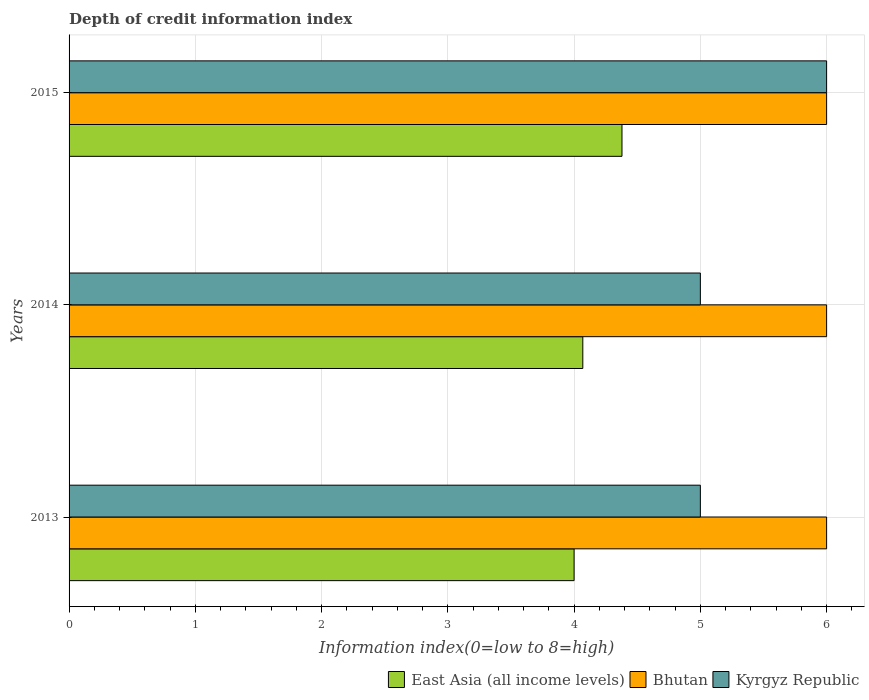How many groups of bars are there?
Provide a succinct answer. 3. Are the number of bars on each tick of the Y-axis equal?
Your answer should be compact. Yes. How many bars are there on the 1st tick from the bottom?
Ensure brevity in your answer.  3. Across all years, what is the maximum information index in East Asia (all income levels)?
Make the answer very short. 4.38. In which year was the information index in East Asia (all income levels) maximum?
Offer a very short reply. 2015. What is the total information index in Bhutan in the graph?
Your answer should be very brief. 18. What is the difference between the information index in Kyrgyz Republic in 2013 and the information index in Bhutan in 2015?
Your answer should be very brief. -1. What is the average information index in Bhutan per year?
Provide a short and direct response. 6. In the year 2013, what is the difference between the information index in Kyrgyz Republic and information index in East Asia (all income levels)?
Offer a terse response. 1. In how many years, is the information index in East Asia (all income levels) greater than 3.4 ?
Offer a terse response. 3. What is the ratio of the information index in Kyrgyz Republic in 2013 to that in 2014?
Offer a terse response. 1. Is the difference between the information index in Kyrgyz Republic in 2013 and 2015 greater than the difference between the information index in East Asia (all income levels) in 2013 and 2015?
Give a very brief answer. No. What is the difference between the highest and the lowest information index in Kyrgyz Republic?
Provide a succinct answer. 1. What does the 2nd bar from the top in 2015 represents?
Give a very brief answer. Bhutan. What does the 1st bar from the bottom in 2014 represents?
Your response must be concise. East Asia (all income levels). How many bars are there?
Make the answer very short. 9. Are all the bars in the graph horizontal?
Make the answer very short. Yes. What is the difference between two consecutive major ticks on the X-axis?
Your answer should be very brief. 1. Does the graph contain any zero values?
Make the answer very short. No. Where does the legend appear in the graph?
Offer a very short reply. Bottom right. How many legend labels are there?
Keep it short and to the point. 3. What is the title of the graph?
Offer a very short reply. Depth of credit information index. What is the label or title of the X-axis?
Your answer should be very brief. Information index(0=low to 8=high). What is the Information index(0=low to 8=high) of East Asia (all income levels) in 2013?
Make the answer very short. 4. What is the Information index(0=low to 8=high) in Bhutan in 2013?
Give a very brief answer. 6. What is the Information index(0=low to 8=high) in East Asia (all income levels) in 2014?
Your answer should be compact. 4.07. What is the Information index(0=low to 8=high) in Bhutan in 2014?
Offer a very short reply. 6. What is the Information index(0=low to 8=high) in East Asia (all income levels) in 2015?
Give a very brief answer. 4.38. Across all years, what is the maximum Information index(0=low to 8=high) in East Asia (all income levels)?
Your response must be concise. 4.38. Across all years, what is the maximum Information index(0=low to 8=high) in Bhutan?
Provide a short and direct response. 6. Across all years, what is the maximum Information index(0=low to 8=high) of Kyrgyz Republic?
Offer a terse response. 6. What is the total Information index(0=low to 8=high) of East Asia (all income levels) in the graph?
Offer a terse response. 12.45. What is the total Information index(0=low to 8=high) in Kyrgyz Republic in the graph?
Make the answer very short. 16. What is the difference between the Information index(0=low to 8=high) of East Asia (all income levels) in 2013 and that in 2014?
Ensure brevity in your answer.  -0.07. What is the difference between the Information index(0=low to 8=high) in East Asia (all income levels) in 2013 and that in 2015?
Your answer should be very brief. -0.38. What is the difference between the Information index(0=low to 8=high) in Bhutan in 2013 and that in 2015?
Your answer should be very brief. 0. What is the difference between the Information index(0=low to 8=high) in East Asia (all income levels) in 2014 and that in 2015?
Keep it short and to the point. -0.31. What is the difference between the Information index(0=low to 8=high) of East Asia (all income levels) in 2013 and the Information index(0=low to 8=high) of Kyrgyz Republic in 2014?
Provide a short and direct response. -1. What is the difference between the Information index(0=low to 8=high) in East Asia (all income levels) in 2013 and the Information index(0=low to 8=high) in Bhutan in 2015?
Make the answer very short. -2. What is the difference between the Information index(0=low to 8=high) of Bhutan in 2013 and the Information index(0=low to 8=high) of Kyrgyz Republic in 2015?
Provide a succinct answer. 0. What is the difference between the Information index(0=low to 8=high) in East Asia (all income levels) in 2014 and the Information index(0=low to 8=high) in Bhutan in 2015?
Keep it short and to the point. -1.93. What is the difference between the Information index(0=low to 8=high) in East Asia (all income levels) in 2014 and the Information index(0=low to 8=high) in Kyrgyz Republic in 2015?
Ensure brevity in your answer.  -1.93. What is the difference between the Information index(0=low to 8=high) of Bhutan in 2014 and the Information index(0=low to 8=high) of Kyrgyz Republic in 2015?
Give a very brief answer. 0. What is the average Information index(0=low to 8=high) of East Asia (all income levels) per year?
Offer a terse response. 4.15. What is the average Information index(0=low to 8=high) of Bhutan per year?
Offer a very short reply. 6. What is the average Information index(0=low to 8=high) in Kyrgyz Republic per year?
Offer a very short reply. 5.33. In the year 2013, what is the difference between the Information index(0=low to 8=high) of East Asia (all income levels) and Information index(0=low to 8=high) of Bhutan?
Provide a succinct answer. -2. In the year 2013, what is the difference between the Information index(0=low to 8=high) of East Asia (all income levels) and Information index(0=low to 8=high) of Kyrgyz Republic?
Offer a very short reply. -1. In the year 2014, what is the difference between the Information index(0=low to 8=high) of East Asia (all income levels) and Information index(0=low to 8=high) of Bhutan?
Offer a terse response. -1.93. In the year 2014, what is the difference between the Information index(0=low to 8=high) of East Asia (all income levels) and Information index(0=low to 8=high) of Kyrgyz Republic?
Provide a succinct answer. -0.93. In the year 2014, what is the difference between the Information index(0=low to 8=high) in Bhutan and Information index(0=low to 8=high) in Kyrgyz Republic?
Ensure brevity in your answer.  1. In the year 2015, what is the difference between the Information index(0=low to 8=high) in East Asia (all income levels) and Information index(0=low to 8=high) in Bhutan?
Your answer should be very brief. -1.62. In the year 2015, what is the difference between the Information index(0=low to 8=high) of East Asia (all income levels) and Information index(0=low to 8=high) of Kyrgyz Republic?
Your answer should be compact. -1.62. In the year 2015, what is the difference between the Information index(0=low to 8=high) in Bhutan and Information index(0=low to 8=high) in Kyrgyz Republic?
Make the answer very short. 0. What is the ratio of the Information index(0=low to 8=high) in East Asia (all income levels) in 2013 to that in 2014?
Keep it short and to the point. 0.98. What is the ratio of the Information index(0=low to 8=high) of Kyrgyz Republic in 2013 to that in 2014?
Provide a succinct answer. 1. What is the ratio of the Information index(0=low to 8=high) of East Asia (all income levels) in 2013 to that in 2015?
Keep it short and to the point. 0.91. What is the ratio of the Information index(0=low to 8=high) in Bhutan in 2013 to that in 2015?
Make the answer very short. 1. What is the ratio of the Information index(0=low to 8=high) of East Asia (all income levels) in 2014 to that in 2015?
Keep it short and to the point. 0.93. What is the ratio of the Information index(0=low to 8=high) of Bhutan in 2014 to that in 2015?
Give a very brief answer. 1. What is the ratio of the Information index(0=low to 8=high) in Kyrgyz Republic in 2014 to that in 2015?
Offer a very short reply. 0.83. What is the difference between the highest and the second highest Information index(0=low to 8=high) in East Asia (all income levels)?
Make the answer very short. 0.31. What is the difference between the highest and the lowest Information index(0=low to 8=high) of East Asia (all income levels)?
Your answer should be compact. 0.38. What is the difference between the highest and the lowest Information index(0=low to 8=high) in Bhutan?
Offer a terse response. 0. What is the difference between the highest and the lowest Information index(0=low to 8=high) of Kyrgyz Republic?
Offer a very short reply. 1. 